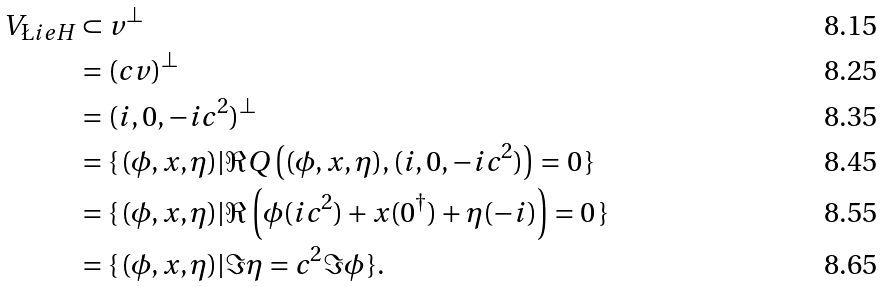Convert formula to latex. <formula><loc_0><loc_0><loc_500><loc_500>V _ { \L i e H } & \subset v ^ { \perp } \\ & = ( c v ) ^ { \perp } \\ & = ( i , 0 , - i c ^ { 2 } ) ^ { \perp } \\ & = \{ \, ( \phi , x , \eta ) | \Re Q \left ( ( \phi , x , \eta ) , ( i , 0 , - i c ^ { 2 } ) \right ) = 0 \, \} \\ & = \{ \, ( \phi , x , \eta ) | \Re \left ( \phi ( i c ^ { 2 } ) + x ( 0 ^ { \dagger } ) + \eta ( - i ) \right ) = 0 \, \} \\ & = \{ \, ( \phi , x , \eta ) | \Im \eta = c ^ { 2 } \Im \phi \, \} .</formula> 